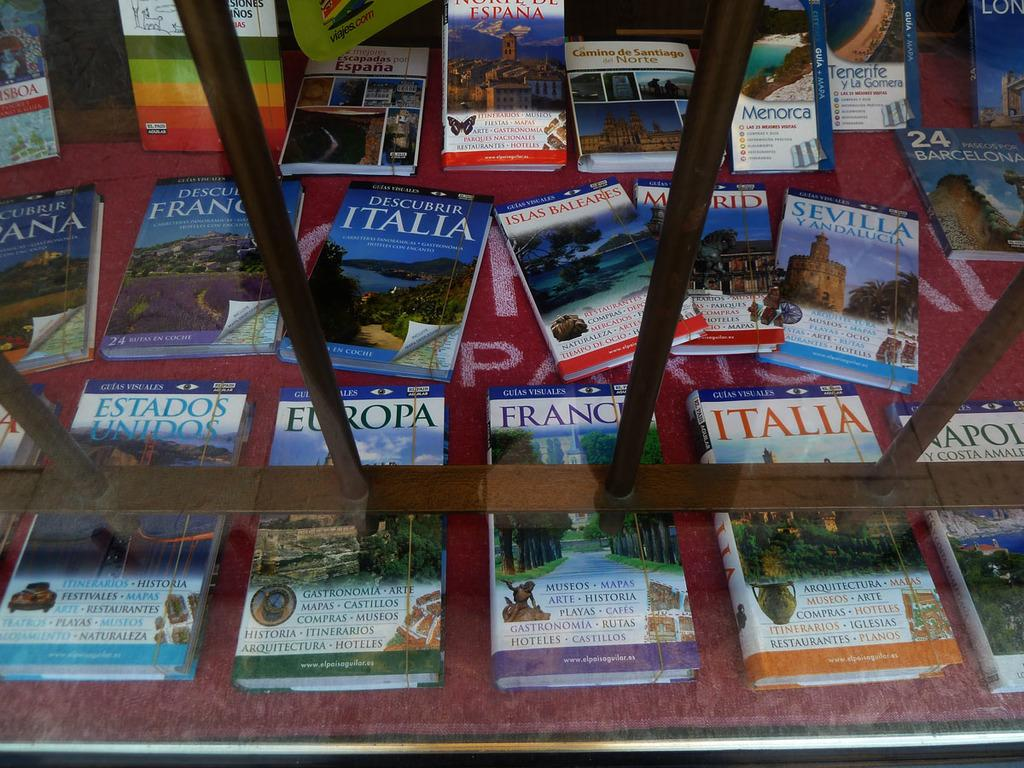<image>
Summarize the visual content of the image. Various guide books for European countries including France and Italy. 